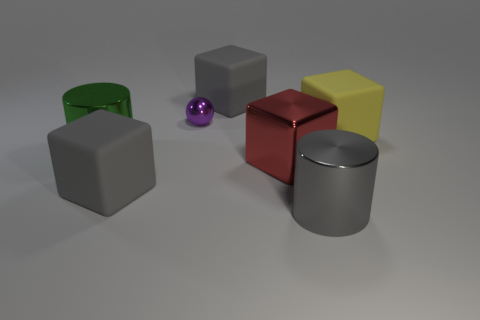Subtract all blue blocks. Subtract all gray spheres. How many blocks are left? 4 Add 2 big rubber objects. How many objects exist? 9 Subtract all cylinders. How many objects are left? 5 Add 3 big cubes. How many big cubes are left? 7 Add 6 red shiny things. How many red shiny things exist? 7 Subtract 0 gray spheres. How many objects are left? 7 Subtract all tiny brown rubber blocks. Subtract all large metallic cubes. How many objects are left? 6 